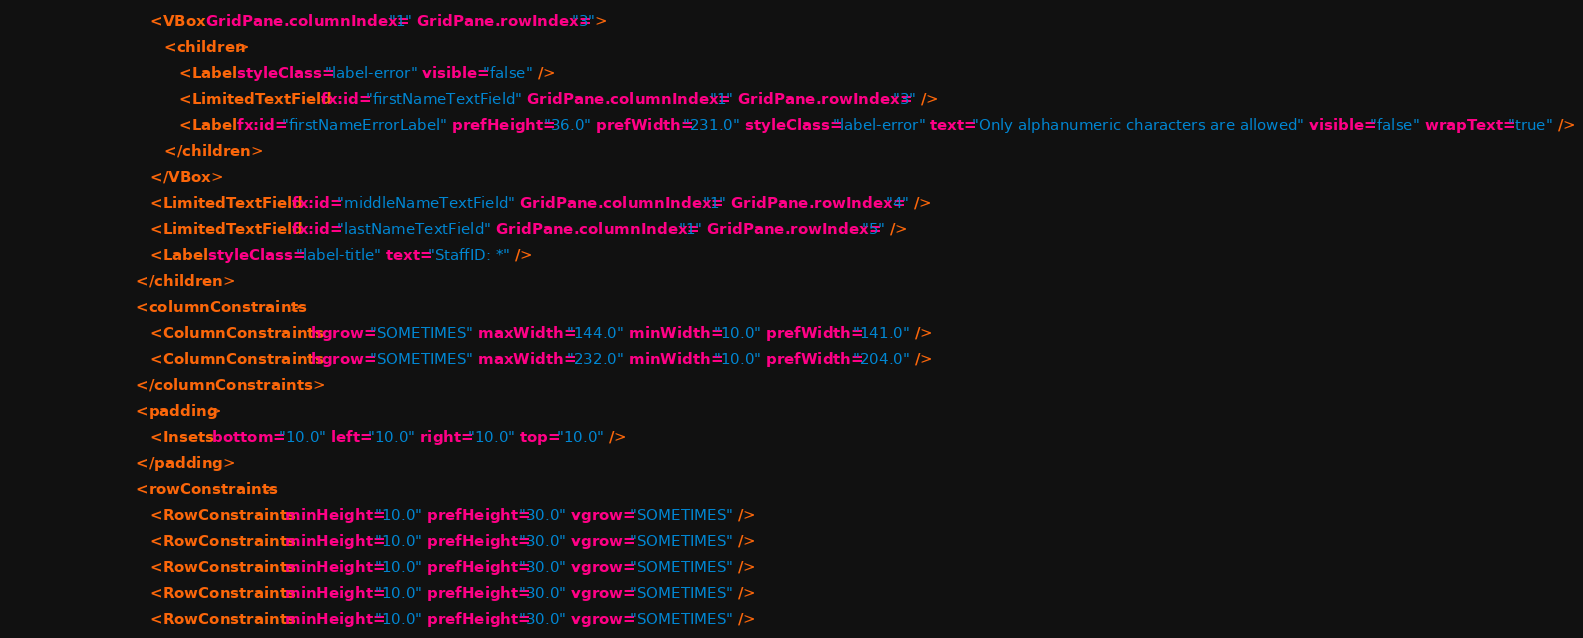<code> <loc_0><loc_0><loc_500><loc_500><_XML_>                              <VBox GridPane.columnIndex="1" GridPane.rowIndex="3">
                                 <children>
                                    <Label styleClass="label-error" visible="false" />
                                    <LimitedTextField fx:id="firstNameTextField" GridPane.columnIndex="1" GridPane.rowIndex="3" />
                                    <Label fx:id="firstNameErrorLabel" prefHeight="36.0" prefWidth="231.0" styleClass="label-error" text="Only alphanumeric characters are allowed" visible="false" wrapText="true" />
                                 </children>
                              </VBox>
                              <LimitedTextField fx:id="middleNameTextField" GridPane.columnIndex="1" GridPane.rowIndex="4" />
                              <LimitedTextField fx:id="lastNameTextField" GridPane.columnIndex="1" GridPane.rowIndex="5" />
                              <Label styleClass="label-title" text="StaffID: *" />
                           </children>
                           <columnConstraints>
                              <ColumnConstraints hgrow="SOMETIMES" maxWidth="144.0" minWidth="10.0" prefWidth="141.0" />
                              <ColumnConstraints hgrow="SOMETIMES" maxWidth="232.0" minWidth="10.0" prefWidth="204.0" />
                           </columnConstraints>
                           <padding>
                              <Insets bottom="10.0" left="10.0" right="10.0" top="10.0" />
                           </padding>
                           <rowConstraints>
                              <RowConstraints minHeight="10.0" prefHeight="30.0" vgrow="SOMETIMES" />
                              <RowConstraints minHeight="10.0" prefHeight="30.0" vgrow="SOMETIMES" />
                              <RowConstraints minHeight="10.0" prefHeight="30.0" vgrow="SOMETIMES" />
                              <RowConstraints minHeight="10.0" prefHeight="30.0" vgrow="SOMETIMES" />
                              <RowConstraints minHeight="10.0" prefHeight="30.0" vgrow="SOMETIMES" /></code> 